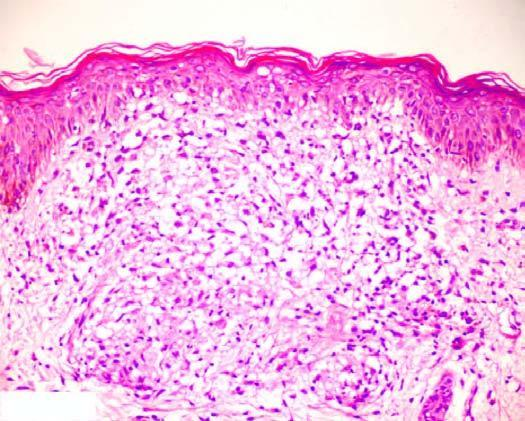what is composed of epithelioid cells with sparse langhans ' giant cells and lymphocytes?
Answer the question using a single word or phrase. Granuloma 